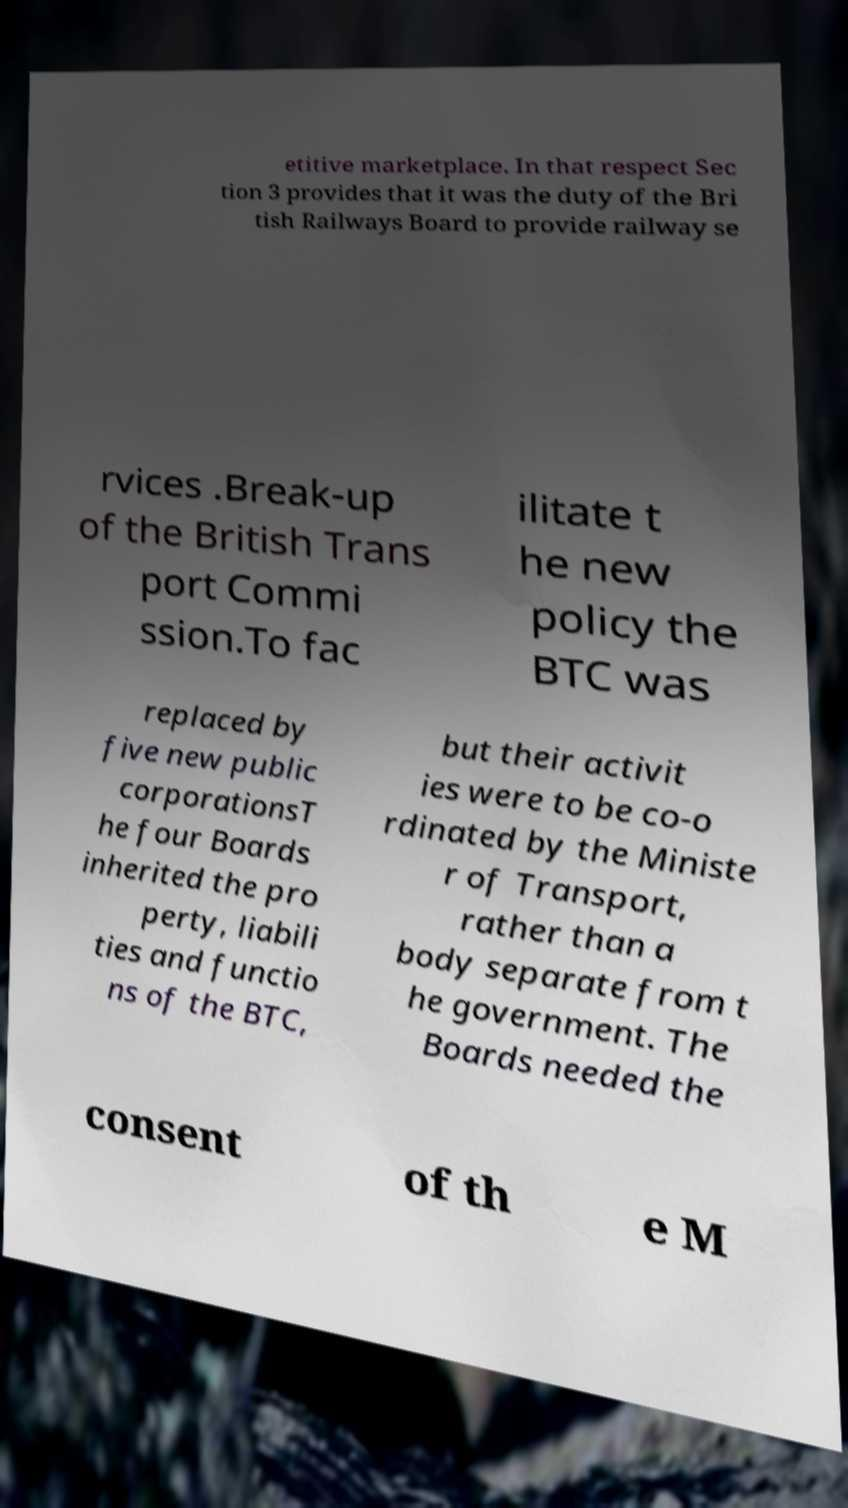Could you assist in decoding the text presented in this image and type it out clearly? etitive marketplace. In that respect Sec tion 3 provides that it was the duty of the Bri tish Railways Board to provide railway se rvices .Break-up of the British Trans port Commi ssion.To fac ilitate t he new policy the BTC was replaced by five new public corporationsT he four Boards inherited the pro perty, liabili ties and functio ns of the BTC, but their activit ies were to be co-o rdinated by the Ministe r of Transport, rather than a body separate from t he government. The Boards needed the consent of th e M 